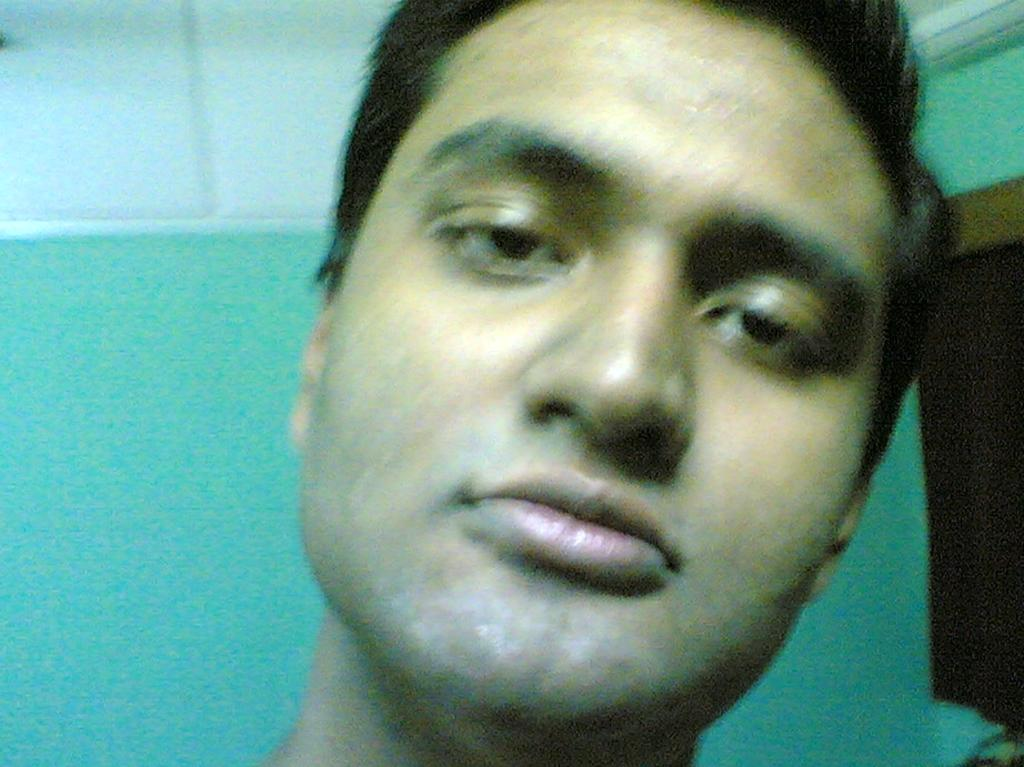What is the main subject of the image? There is a person's face in the center of the image. What can be seen behind the person's face? There is a wall in the background of the image. What type of cakes are being served in the afternoon in the image? There are no cakes or references to time of day in the image; it only features a person's face and a wall in the background. 